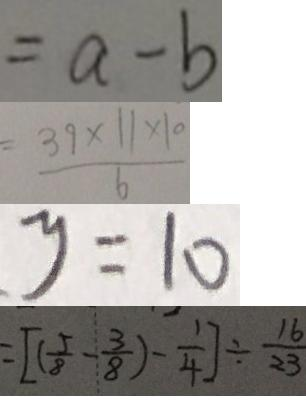Convert formula to latex. <formula><loc_0><loc_0><loc_500><loc_500>= a - b 
 = \frac { 3 9 \times 1 1 \times 1 0 } { 6 } 
 y = 1 0 
 = [ ( \frac { 5 } { 8 } - \frac { 3 } { 8 } ) - \frac { 1 } { 4 } ] \div \frac { 1 6 } { 2 3 }</formula> 